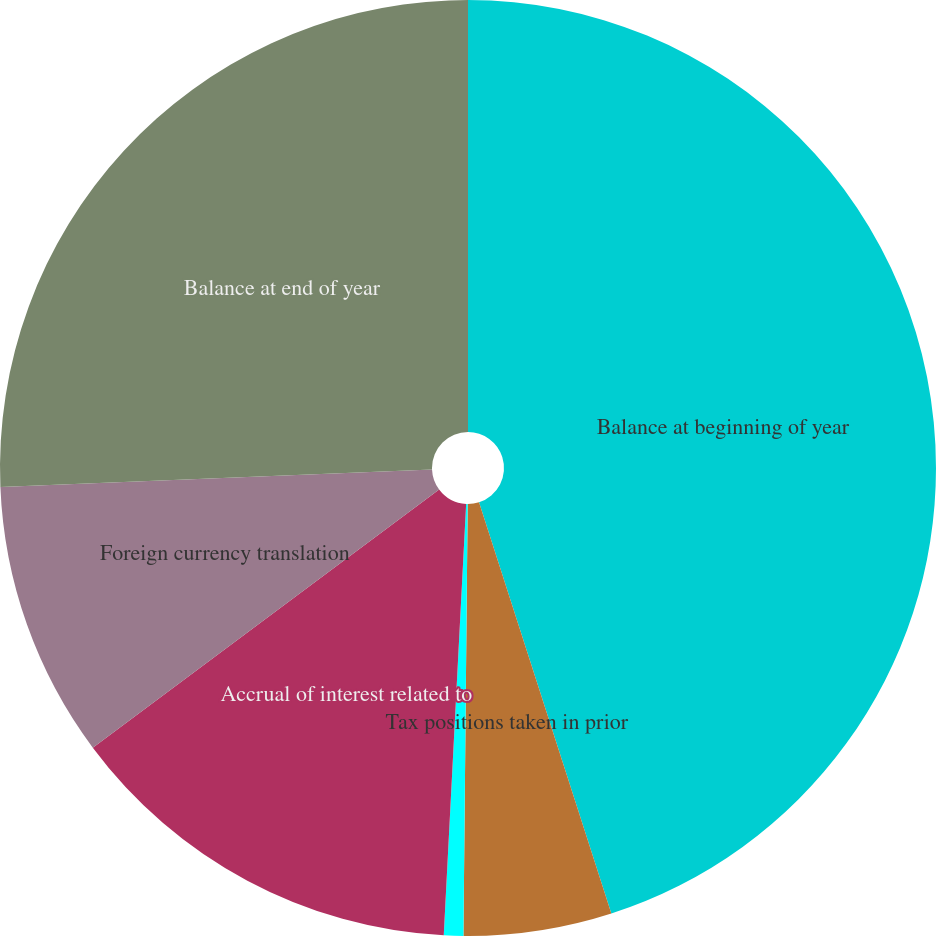<chart> <loc_0><loc_0><loc_500><loc_500><pie_chart><fcel>Balance at beginning of year<fcel>Tax positions taken in prior<fcel>Tax positions taken in current<fcel>Accrual of interest related to<fcel>Foreign currency translation<fcel>Balance at end of year<nl><fcel>45.05%<fcel>5.11%<fcel>0.67%<fcel>13.98%<fcel>9.55%<fcel>25.65%<nl></chart> 